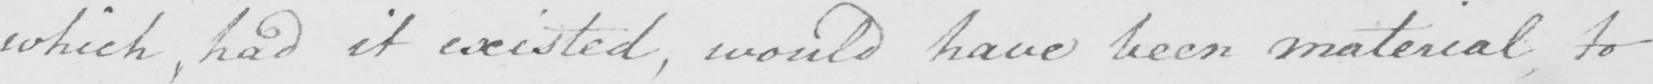Please provide the text content of this handwritten line. which , had it existed , would have been material to 